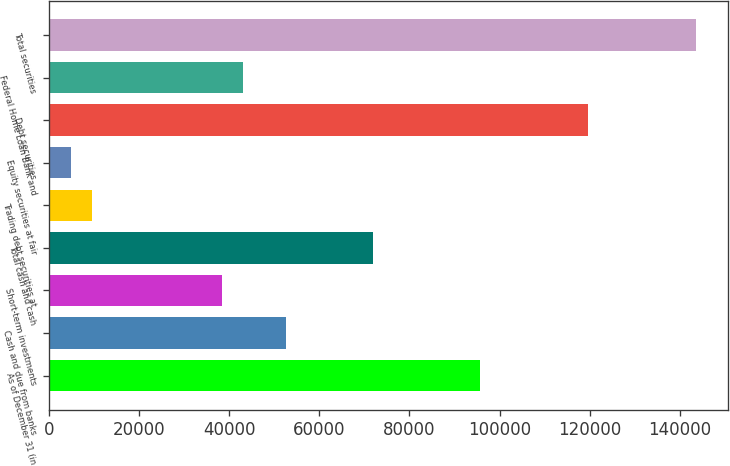Convert chart to OTSL. <chart><loc_0><loc_0><loc_500><loc_500><bar_chart><fcel>As of December 31 (in<fcel>Cash and due from banks<fcel>Short-term investments<fcel>Total cash and cash<fcel>Trading debt securities at<fcel>Equity securities at fair<fcel>Debt securities<fcel>Federal Home Loan Bank and<fcel>Total securities<nl><fcel>95749.9<fcel>52664.6<fcel>38302.8<fcel>71813.6<fcel>9579.22<fcel>4791.96<fcel>119686<fcel>43090<fcel>143622<nl></chart> 